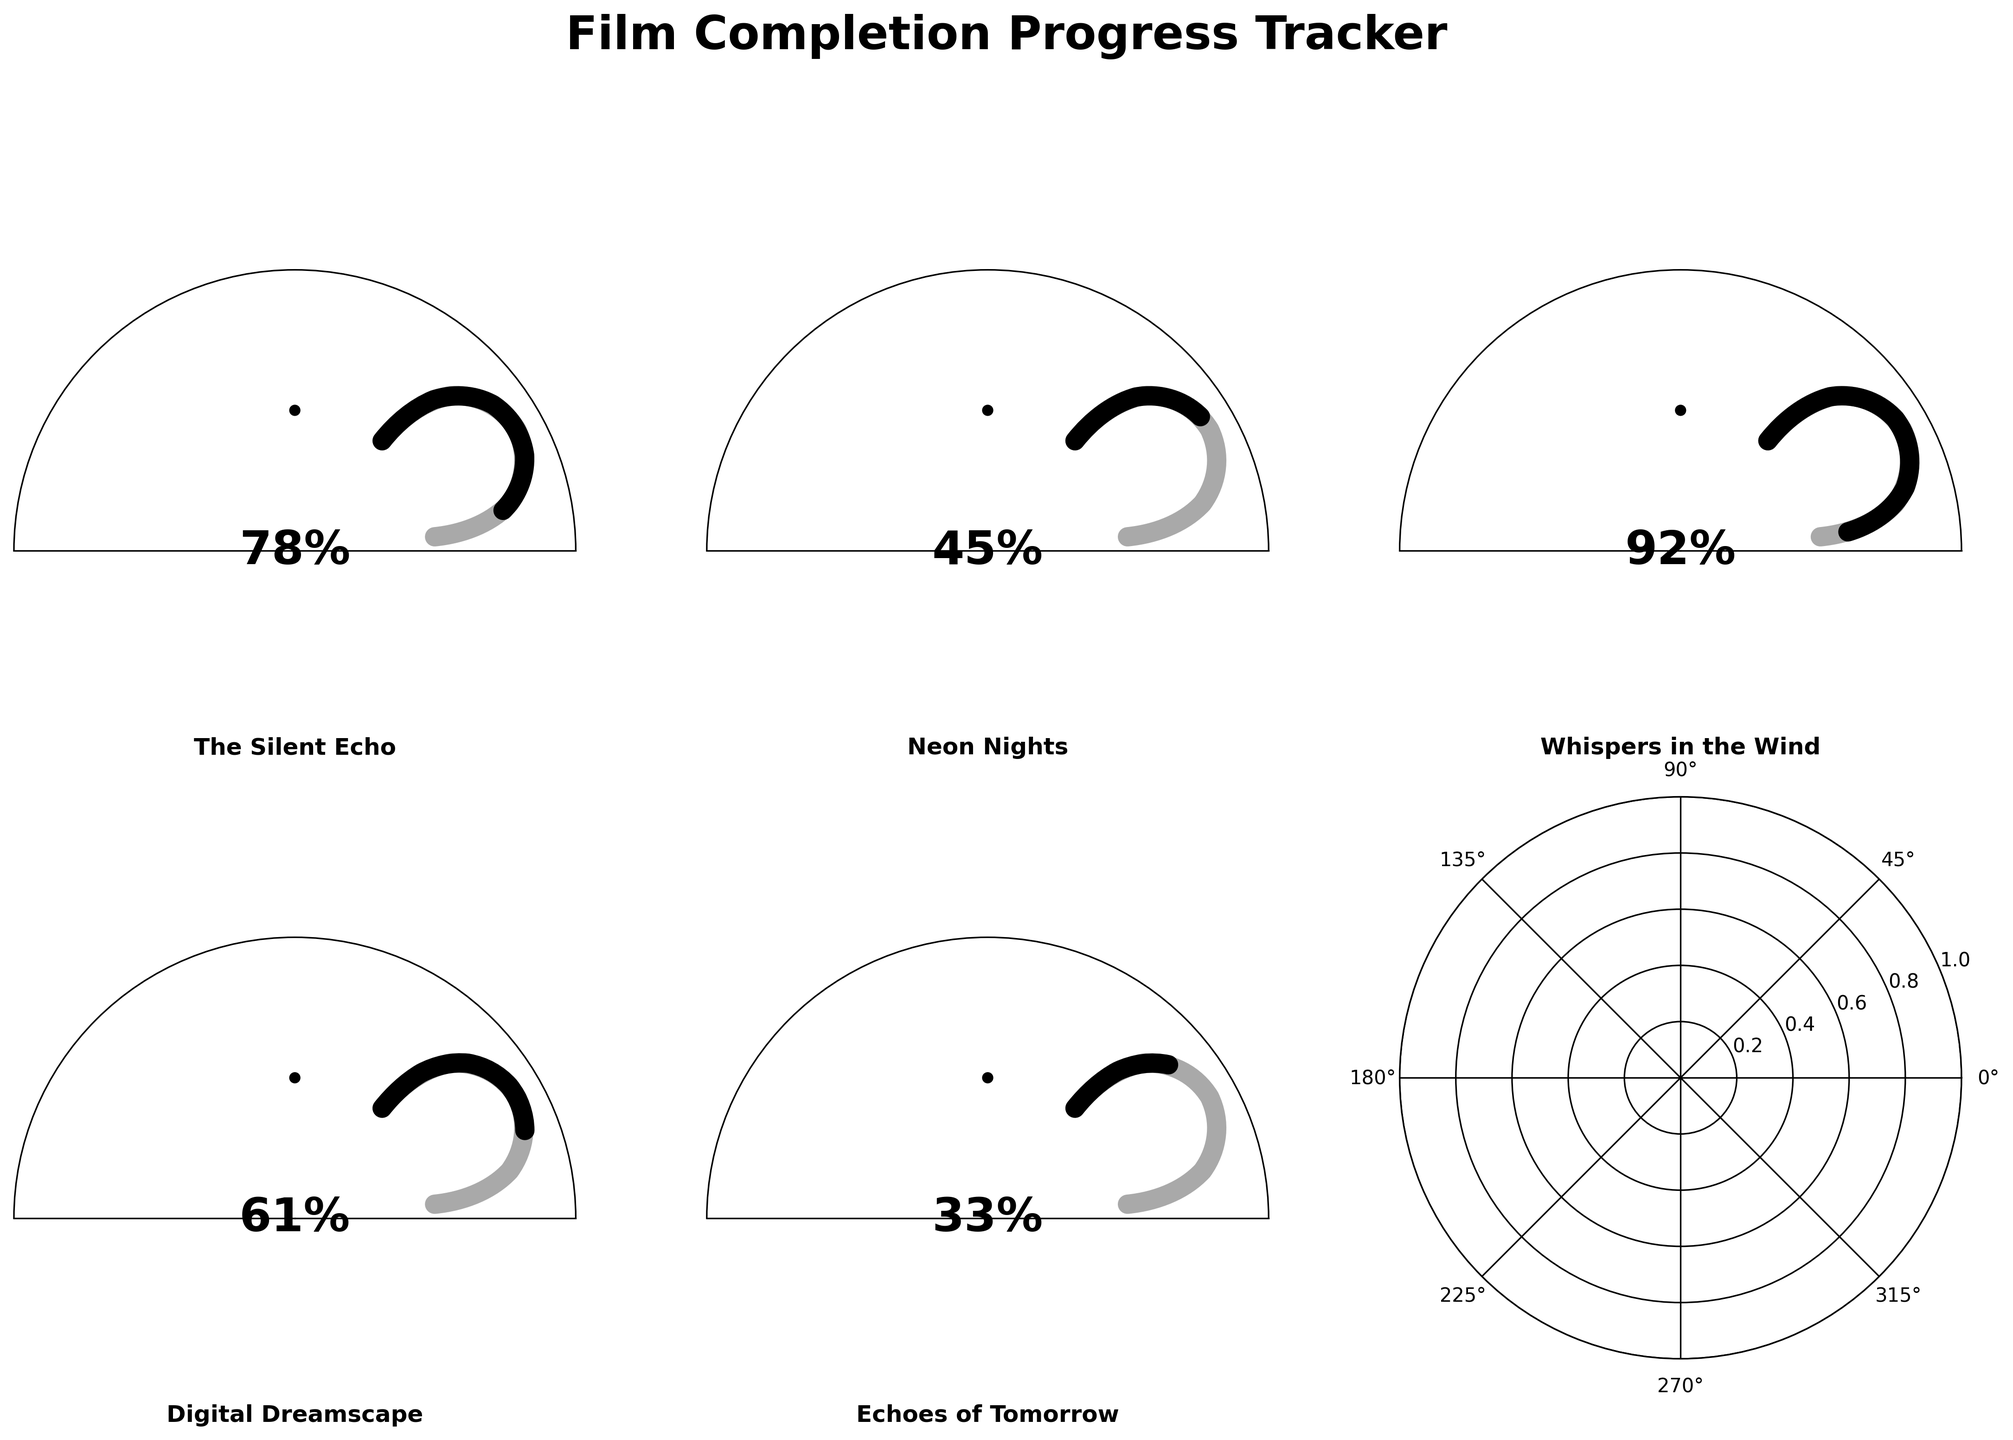Which film has the highest completion percentage? "Whispers in the Wind" shows a 92% completion rate, which is visibly higher than any other film's percentage in the figure.
Answer: "Whispers in the Wind" Which film is the least complete? "Echoes of Tomorrow" has the lowest progress with only 33% completion visible in the gauge chart.
Answer: "Echoes of Tomorrow" What's the average completion percentage of all films? Add the completion percentages of all films and divide by the number of films: (78 + 45 + 92 + 61 + 33) / 5 = 61.8%
Answer: 61.8% How many films have completed more than 50% of their production? Identify films with more than 50% completion: "The Silent Echo" (78%), "Whispers in the Wind" (92%), and "Digital Dreamscape" (61%). Three films meet this criteria.
Answer: 3 What percentage is "Neon Nights" complete? The gauge for "Neon Nights" shows a completion of 45%.
Answer: 45% If the goal is to reach 100% for each film, which film needs the most additional effort to complete? "The Echoes of Tomorrow" is at 33% complete, so it needs 67% more effort, which is the highest needed among all films shown.
Answer: "Echoes of Tomorrow" Which films are more than halfway complete? Films with more than 50% completion are "The Silent Echo" (78%), "Whispers in the Wind" (92%), and "Digital Dreamscape" (61%).
Answer: "The Silent Echo", "Whispers in the Wind", "Digital Dreamscape" 